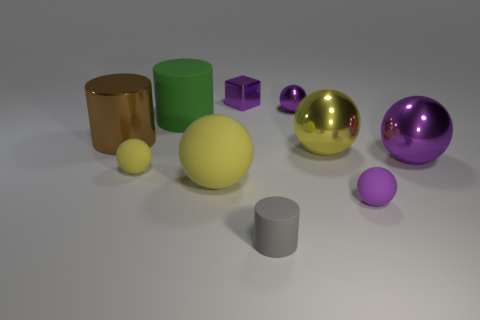What is the shape of the big object that is the same color as the small shiny ball?
Your answer should be compact. Sphere. The yellow object that is the same material as the brown thing is what size?
Provide a short and direct response. Large. How many balls are the same size as the shiny cylinder?
Provide a succinct answer. 3. Do the green object and the yellow metallic object have the same shape?
Make the answer very short. No. There is a matte ball that is to the left of the matte cylinder that is on the left side of the small matte cylinder; what is its color?
Your response must be concise. Yellow. There is a purple metal thing that is both in front of the block and behind the brown metallic cylinder; what is its size?
Offer a terse response. Small. Is there anything else of the same color as the small shiny block?
Provide a succinct answer. Yes. What is the shape of the brown thing that is made of the same material as the big purple object?
Your response must be concise. Cylinder. There is a large yellow rubber object; does it have the same shape as the big yellow object on the right side of the purple block?
Your response must be concise. Yes. The thing that is behind the tiny purple metal object that is in front of the metal cube is made of what material?
Give a very brief answer. Metal. 